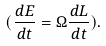<formula> <loc_0><loc_0><loc_500><loc_500>( \frac { d E } { d t } = \Omega \frac { d L } { d t } ) .</formula> 